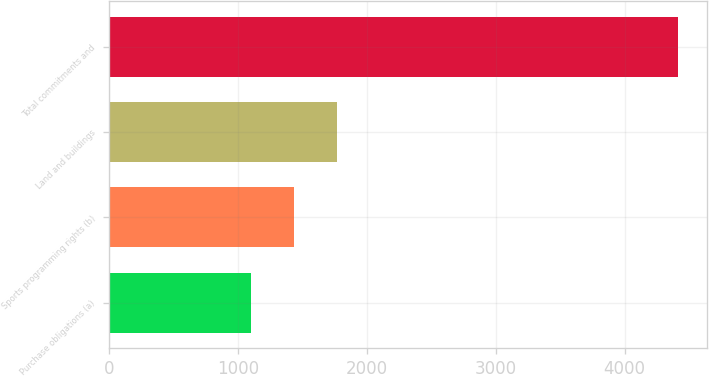<chart> <loc_0><loc_0><loc_500><loc_500><bar_chart><fcel>Purchase obligations (a)<fcel>Sports programming rights (b)<fcel>Land and buildings<fcel>Total commitments and<nl><fcel>1105<fcel>1436.3<fcel>1767.6<fcel>4418<nl></chart> 